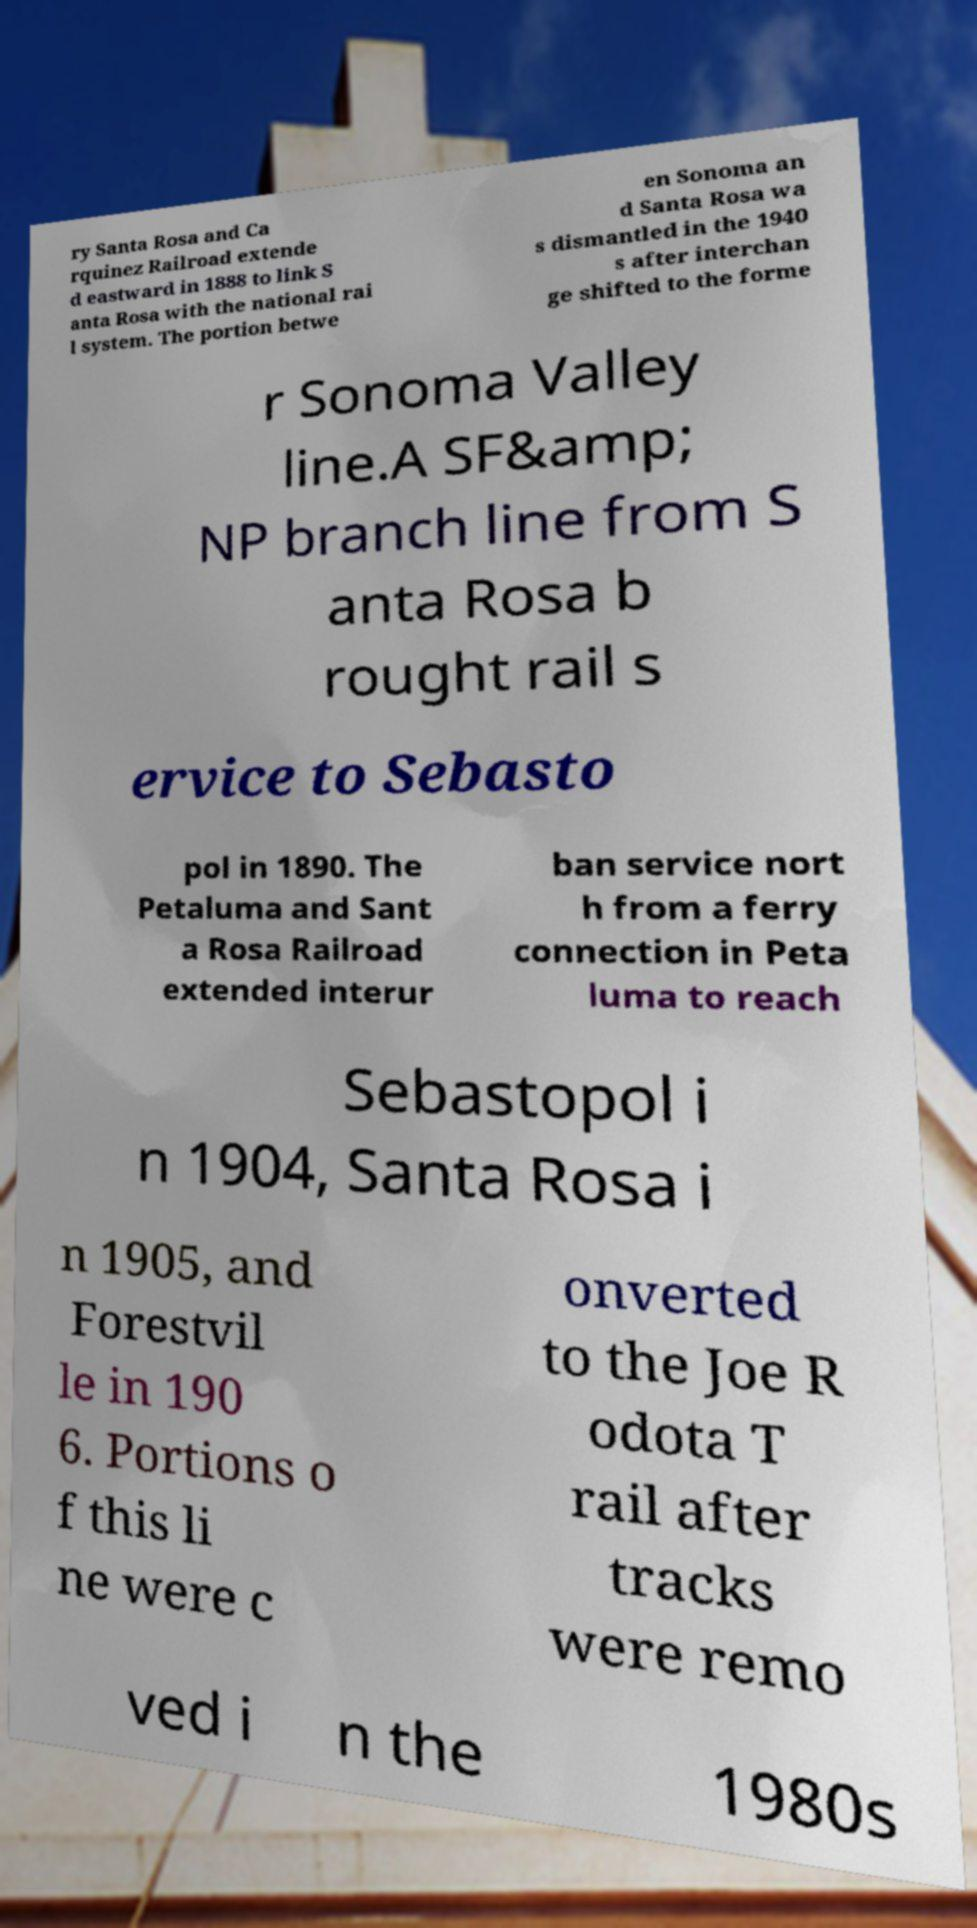For documentation purposes, I need the text within this image transcribed. Could you provide that? ry Santa Rosa and Ca rquinez Railroad extende d eastward in 1888 to link S anta Rosa with the national rai l system. The portion betwe en Sonoma an d Santa Rosa wa s dismantled in the 1940 s after interchan ge shifted to the forme r Sonoma Valley line.A SF&amp; NP branch line from S anta Rosa b rought rail s ervice to Sebasto pol in 1890. The Petaluma and Sant a Rosa Railroad extended interur ban service nort h from a ferry connection in Peta luma to reach Sebastopol i n 1904, Santa Rosa i n 1905, and Forestvil le in 190 6. Portions o f this li ne were c onverted to the Joe R odota T rail after tracks were remo ved i n the 1980s 